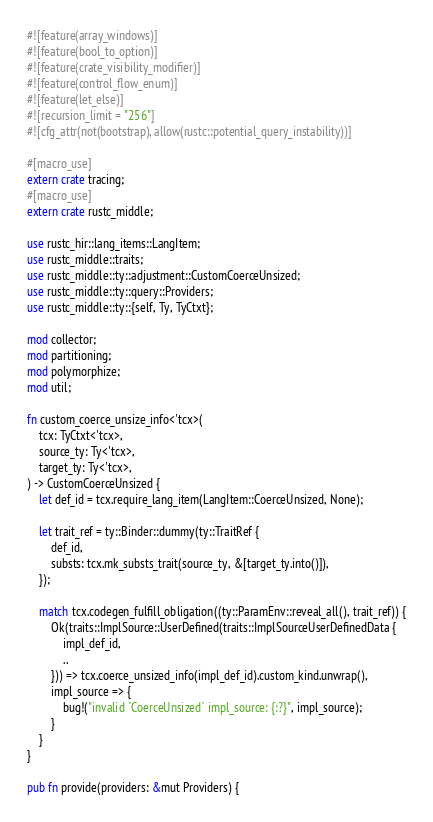<code> <loc_0><loc_0><loc_500><loc_500><_Rust_>#![feature(array_windows)]
#![feature(bool_to_option)]
#![feature(crate_visibility_modifier)]
#![feature(control_flow_enum)]
#![feature(let_else)]
#![recursion_limit = "256"]
#![cfg_attr(not(bootstrap), allow(rustc::potential_query_instability))]

#[macro_use]
extern crate tracing;
#[macro_use]
extern crate rustc_middle;

use rustc_hir::lang_items::LangItem;
use rustc_middle::traits;
use rustc_middle::ty::adjustment::CustomCoerceUnsized;
use rustc_middle::ty::query::Providers;
use rustc_middle::ty::{self, Ty, TyCtxt};

mod collector;
mod partitioning;
mod polymorphize;
mod util;

fn custom_coerce_unsize_info<'tcx>(
    tcx: TyCtxt<'tcx>,
    source_ty: Ty<'tcx>,
    target_ty: Ty<'tcx>,
) -> CustomCoerceUnsized {
    let def_id = tcx.require_lang_item(LangItem::CoerceUnsized, None);

    let trait_ref = ty::Binder::dummy(ty::TraitRef {
        def_id,
        substs: tcx.mk_substs_trait(source_ty, &[target_ty.into()]),
    });

    match tcx.codegen_fulfill_obligation((ty::ParamEnv::reveal_all(), trait_ref)) {
        Ok(traits::ImplSource::UserDefined(traits::ImplSourceUserDefinedData {
            impl_def_id,
            ..
        })) => tcx.coerce_unsized_info(impl_def_id).custom_kind.unwrap(),
        impl_source => {
            bug!("invalid `CoerceUnsized` impl_source: {:?}", impl_source);
        }
    }
}

pub fn provide(providers: &mut Providers) {</code> 